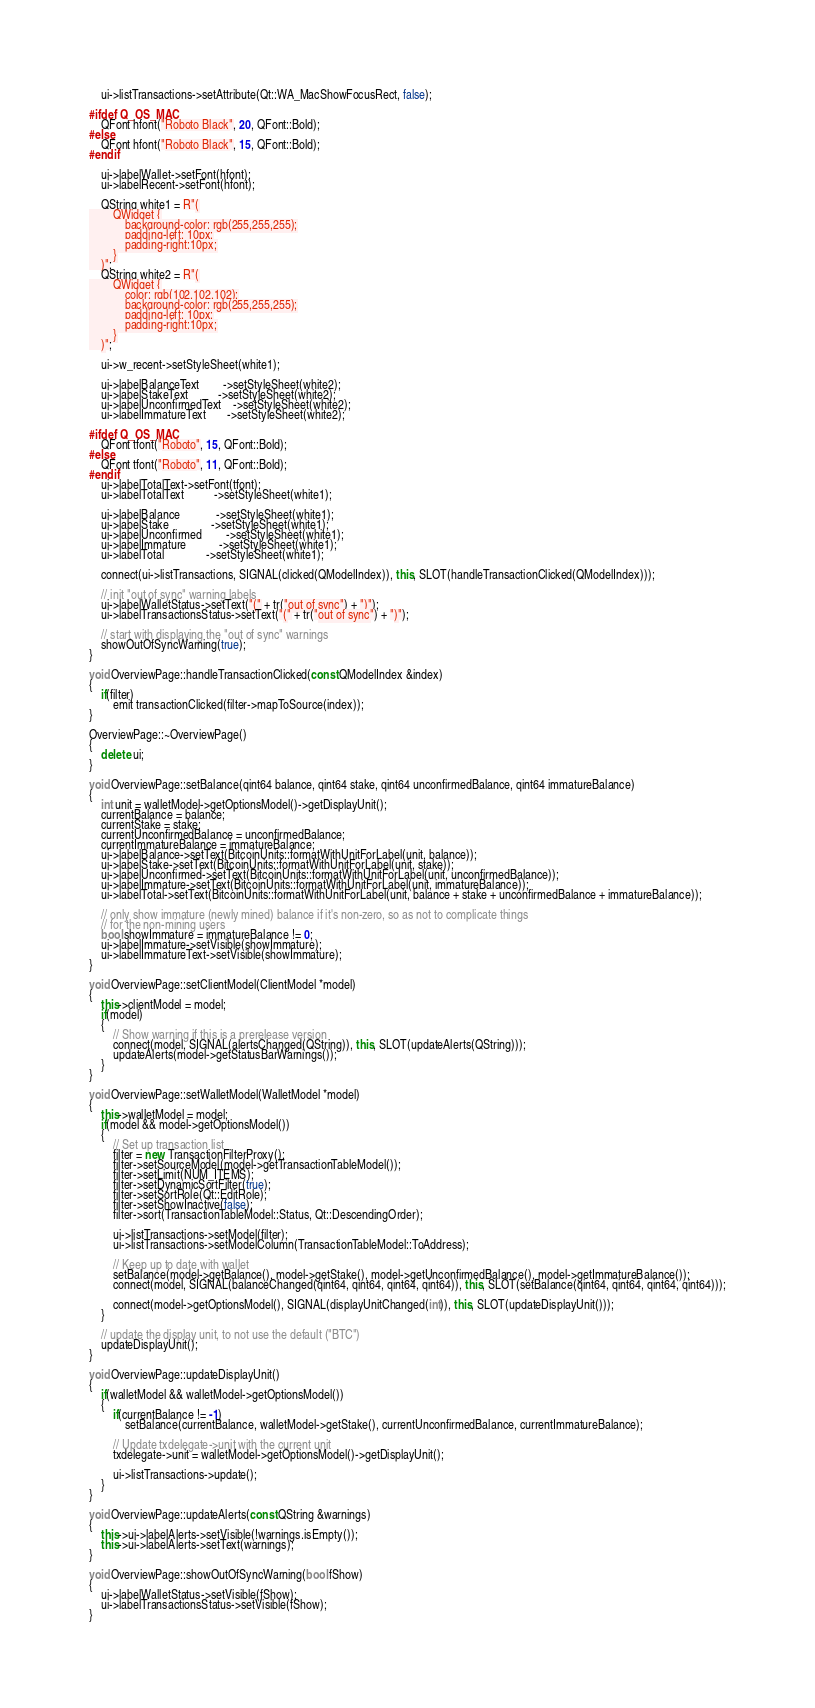Convert code to text. <code><loc_0><loc_0><loc_500><loc_500><_C++_>    ui->listTransactions->setAttribute(Qt::WA_MacShowFocusRect, false);

#ifdef Q_OS_MAC
    QFont hfont("Roboto Black", 20, QFont::Bold);
#else
    QFont hfont("Roboto Black", 15, QFont::Bold);
#endif
    
    ui->labelWallet->setFont(hfont);
    ui->labelRecent->setFont(hfont);

    QString white1 = R"(
        QWidget {
            background-color: rgb(255,255,255);
            padding-left: 10px;
            padding-right:10px;
        }
    )";
    QString white2 = R"(
        QWidget {
            color: rgb(102,102,102);
            background-color: rgb(255,255,255);
            padding-left: 10px;
            padding-right:10px;
        }
    )";

    ui->w_recent->setStyleSheet(white1);

    ui->labelBalanceText        ->setStyleSheet(white2);
    ui->labelStakeText          ->setStyleSheet(white2);
    ui->labelUnconfirmedText    ->setStyleSheet(white2);
    ui->labelImmatureText       ->setStyleSheet(white2);

#ifdef Q_OS_MAC
    QFont tfont("Roboto", 15, QFont::Bold);
#else
    QFont tfont("Roboto", 11, QFont::Bold);
#endif
    ui->labelTotalText->setFont(tfont);
    ui->labelTotalText          ->setStyleSheet(white1);

    ui->labelBalance            ->setStyleSheet(white1);
    ui->labelStake              ->setStyleSheet(white1);
    ui->labelUnconfirmed        ->setStyleSheet(white1);
    ui->labelImmature           ->setStyleSheet(white1);
    ui->labelTotal              ->setStyleSheet(white1);

    connect(ui->listTransactions, SIGNAL(clicked(QModelIndex)), this, SLOT(handleTransactionClicked(QModelIndex)));

    // init "out of sync" warning labels
    ui->labelWalletStatus->setText("(" + tr("out of sync") + ")");
    ui->labelTransactionsStatus->setText("(" + tr("out of sync") + ")");

    // start with displaying the "out of sync" warnings
    showOutOfSyncWarning(true);
}

void OverviewPage::handleTransactionClicked(const QModelIndex &index)
{
    if(filter)
        emit transactionClicked(filter->mapToSource(index));
}

OverviewPage::~OverviewPage()
{
    delete ui;
}

void OverviewPage::setBalance(qint64 balance, qint64 stake, qint64 unconfirmedBalance, qint64 immatureBalance)
{
    int unit = walletModel->getOptionsModel()->getDisplayUnit();
    currentBalance = balance;
    currentStake = stake;
    currentUnconfirmedBalance = unconfirmedBalance;
    currentImmatureBalance = immatureBalance;
    ui->labelBalance->setText(BitcoinUnits::formatWithUnitForLabel(unit, balance));
    ui->labelStake->setText(BitcoinUnits::formatWithUnitForLabel(unit, stake));
    ui->labelUnconfirmed->setText(BitcoinUnits::formatWithUnitForLabel(unit, unconfirmedBalance));
    ui->labelImmature->setText(BitcoinUnits::formatWithUnitForLabel(unit, immatureBalance));
    ui->labelTotal->setText(BitcoinUnits::formatWithUnitForLabel(unit, balance + stake + unconfirmedBalance + immatureBalance));

    // only show immature (newly mined) balance if it's non-zero, so as not to complicate things
    // for the non-mining users
    bool showImmature = immatureBalance != 0;
    ui->labelImmature->setVisible(showImmature);
    ui->labelImmatureText->setVisible(showImmature);
}

void OverviewPage::setClientModel(ClientModel *model)
{
    this->clientModel = model;
    if(model)
    {
        // Show warning if this is a prerelease version
        connect(model, SIGNAL(alertsChanged(QString)), this, SLOT(updateAlerts(QString)));
        updateAlerts(model->getStatusBarWarnings());
    }
}

void OverviewPage::setWalletModel(WalletModel *model)
{
    this->walletModel = model;
    if(model && model->getOptionsModel())
    {
        // Set up transaction list
        filter = new TransactionFilterProxy();
        filter->setSourceModel(model->getTransactionTableModel());
        filter->setLimit(NUM_ITEMS);
        filter->setDynamicSortFilter(true);
        filter->setSortRole(Qt::EditRole);
        filter->setShowInactive(false);
        filter->sort(TransactionTableModel::Status, Qt::DescendingOrder);

        ui->listTransactions->setModel(filter);
        ui->listTransactions->setModelColumn(TransactionTableModel::ToAddress);

        // Keep up to date with wallet
        setBalance(model->getBalance(), model->getStake(), model->getUnconfirmedBalance(), model->getImmatureBalance());
        connect(model, SIGNAL(balanceChanged(qint64, qint64, qint64, qint64)), this, SLOT(setBalance(qint64, qint64, qint64, qint64)));

        connect(model->getOptionsModel(), SIGNAL(displayUnitChanged(int)), this, SLOT(updateDisplayUnit()));
    }

    // update the display unit, to not use the default ("BTC")
    updateDisplayUnit();
}

void OverviewPage::updateDisplayUnit()
{
    if(walletModel && walletModel->getOptionsModel())
    {
        if(currentBalance != -1)
            setBalance(currentBalance, walletModel->getStake(), currentUnconfirmedBalance, currentImmatureBalance);

        // Update txdelegate->unit with the current unit
        txdelegate->unit = walletModel->getOptionsModel()->getDisplayUnit();

        ui->listTransactions->update();
    }
}

void OverviewPage::updateAlerts(const QString &warnings)
{
    this->ui->labelAlerts->setVisible(!warnings.isEmpty());
    this->ui->labelAlerts->setText(warnings);
}

void OverviewPage::showOutOfSyncWarning(bool fShow)
{
    ui->labelWalletStatus->setVisible(fShow);
    ui->labelTransactionsStatus->setVisible(fShow);
}
</code> 